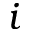<formula> <loc_0><loc_0><loc_500><loc_500>i</formula> 